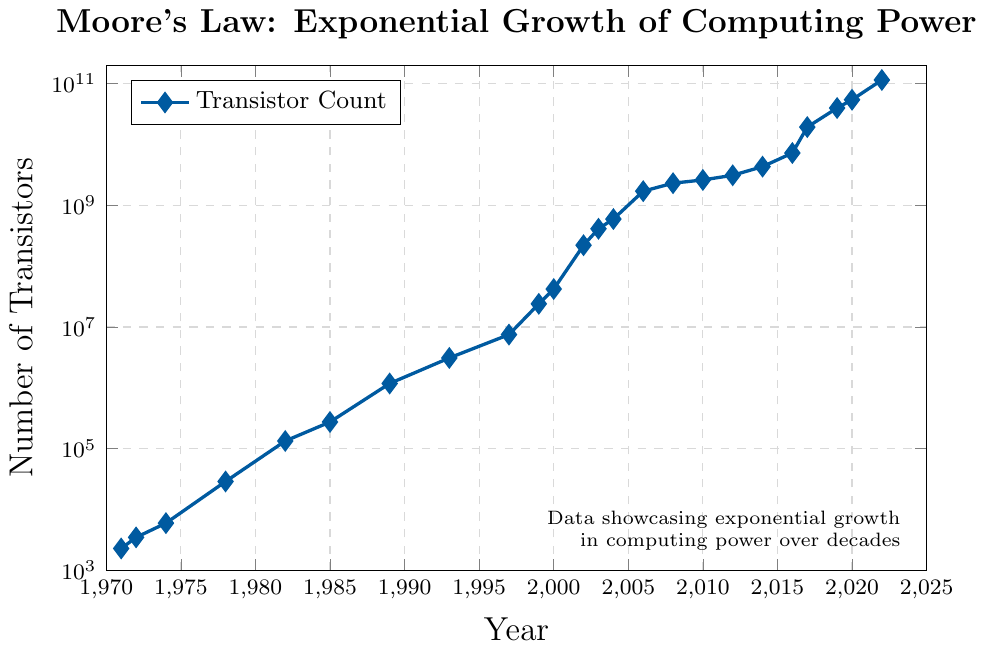What is the general trend of the number of transistors over the years? The figure demonstrates an exponential increase in the number of transistors over time, consistent with Moore's Law. The y-axis is on a logarithmic scale, showing that the number of transistors roughly doubles every couple of years.
Answer: Exponential increase In which year did the number of transistors first exceed one million? Observing the figure, the number of transistors surpassed one million for the first time in 1989.
Answer: 1989 By how many orders of magnitude did the number of transistors increase from 1971 to 2022? In 1971, the number of transistors was 2,300 (approximately \(10^3\)). In 2022, it was 114,000,000,000 (approximately \(10^{11}\)). The increase is 11 - 3 = 8 orders of magnitude.
Answer: 8 Which year experienced the largest increase in the number of transistors between two consecutive data points? To determine this, we compare the increase between each consecutive year shown. The largest leap appears between 2002 (22,000,000) and 2003 (410,000,000), an increase of 188,000,000.
Answer: 2002 to 2003 What color represents the data points in the plot? The color used for plotting the data points is a shade of blue, as observed from the coordinates (X, Y) points marked in the plot.
Answer: Blue What was the number of transistors in 2010? Referring to the figure, in 2010, the number of transistors was approximately 2,600,000,000.
Answer: 2,600,000,000 How has the slope of the data points changed between 1971 and 2022? By examining the logscale chart, the slope of the data points indicates that the growth rate has remained roughly consistent over the decades, aligning with exponential growth and Moore's Law, with more noticeable jumps in the later years.
Answer: Consistent exponential growth What is the difference in the number of transistors between 2000 and 2020? In 2000, the number of transistors was 42,000,000, and in 2020, it was 54,000,000,000. The difference is 54,000,000,000 - 42,000,000 = 53,958,000,000.
Answer: 53,958,000,000 How does the number of transistors in 1985 compare with that in 1993? In 1985, the number of transistors was 275,000, and in 1993 it was 3,100,000, indicating that the number of transistors in 1993 was significantly higher.
Answer: 1993 has more What is the message conveyed by the text at the bottom of the chart? The text at the bottom highlights that the data demonstrates exponential growth in computing power over the decades.
Answer: Exponential growth in computing power 